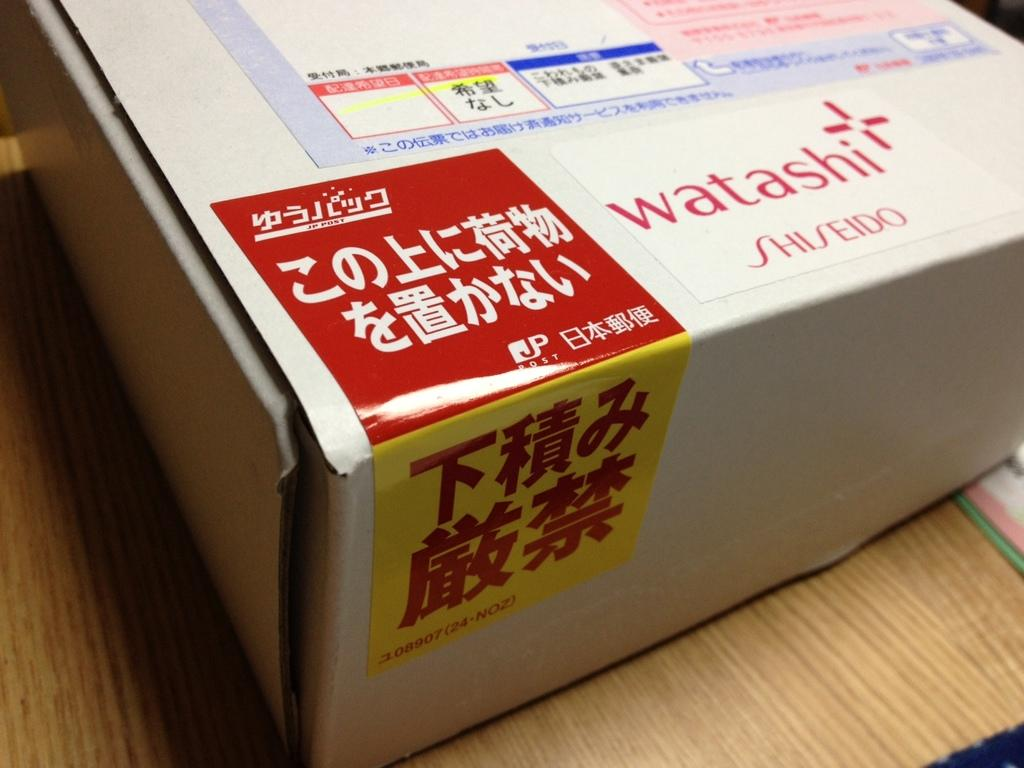<image>
Summarize the visual content of the image. The label on the box says Watashi on it 